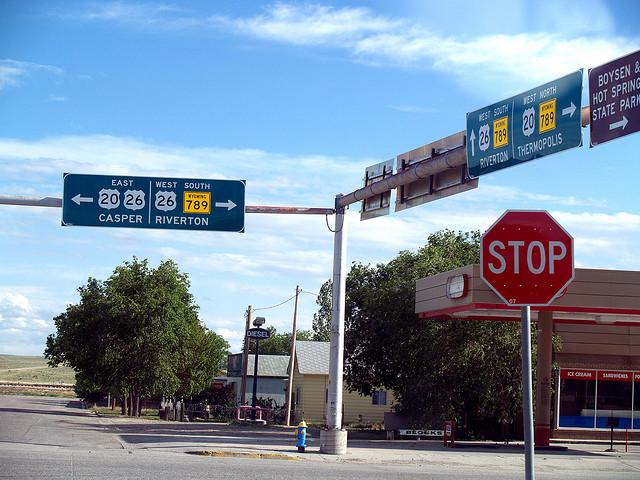What building does the diesel sign most likely foreshadow? gas station 